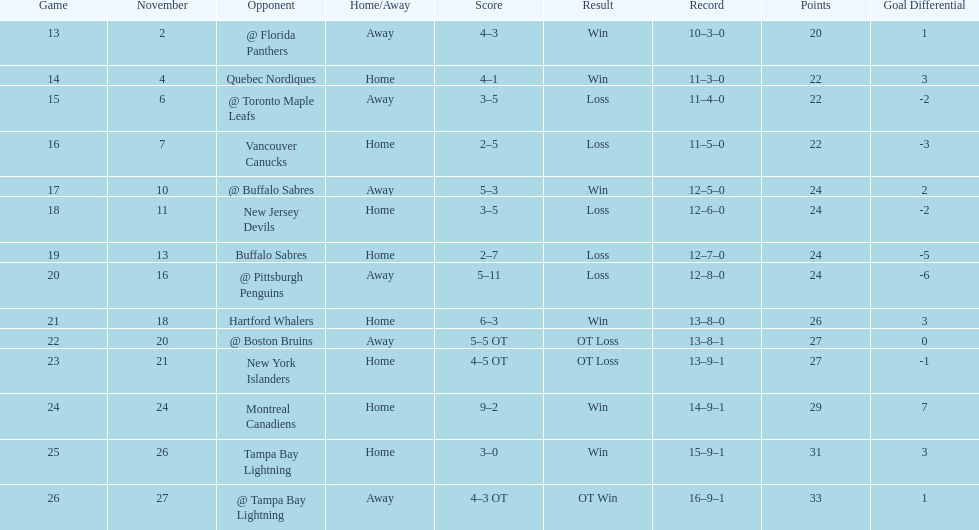What other team had the closest amount of wins? New York Islanders. 